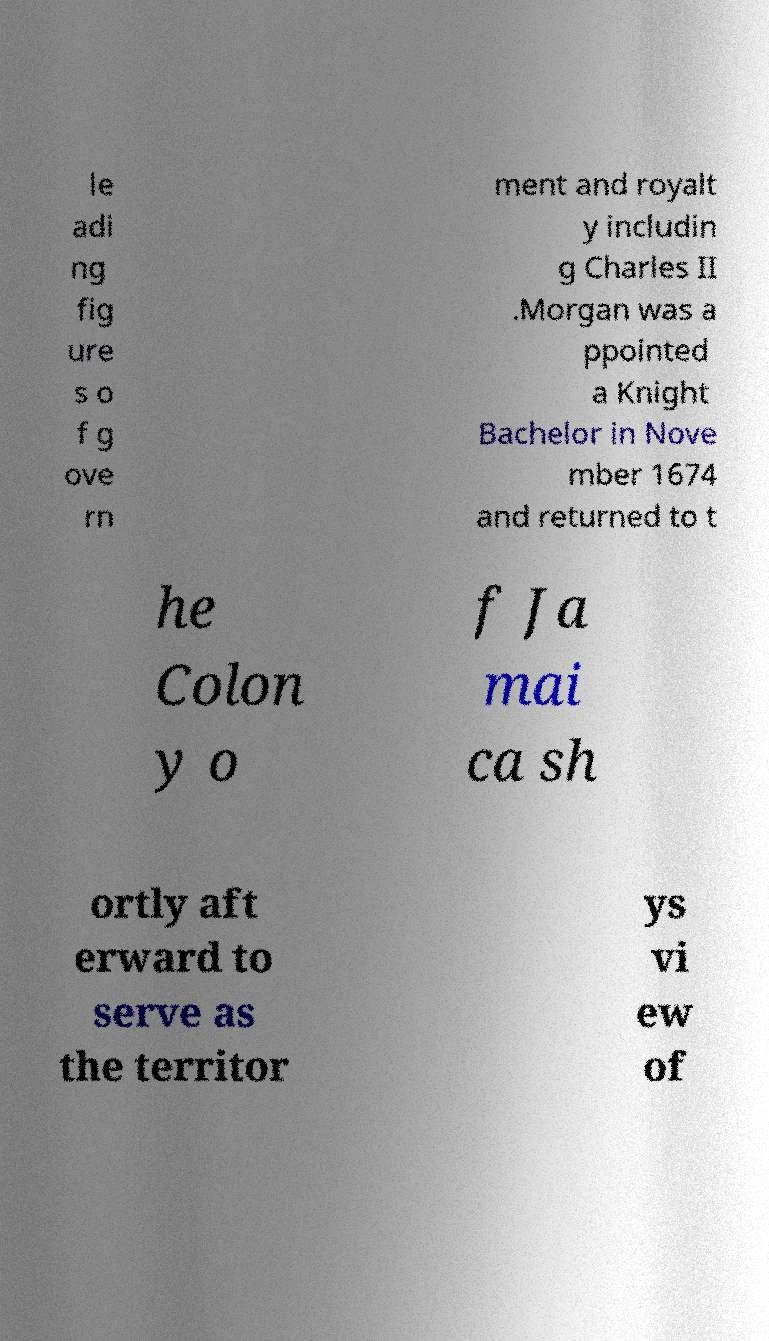I need the written content from this picture converted into text. Can you do that? le adi ng fig ure s o f g ove rn ment and royalt y includin g Charles II .Morgan was a ppointed a Knight Bachelor in Nove mber 1674 and returned to t he Colon y o f Ja mai ca sh ortly aft erward to serve as the territor ys vi ew of 